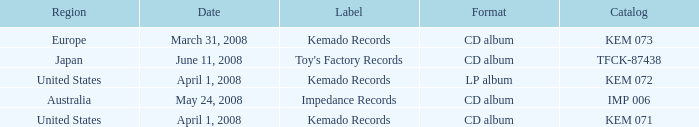Write the full table. {'header': ['Region', 'Date', 'Label', 'Format', 'Catalog'], 'rows': [['Europe', 'March 31, 2008', 'Kemado Records', 'CD album', 'KEM 073'], ['Japan', 'June 11, 2008', "Toy's Factory Records", 'CD album', 'TFCK-87438'], ['United States', 'April 1, 2008', 'Kemado Records', 'LP album', 'KEM 072'], ['Australia', 'May 24, 2008', 'Impedance Records', 'CD album', 'IMP 006'], ['United States', 'April 1, 2008', 'Kemado Records', 'CD album', 'KEM 071']]} Which Region has a Catalog of kem 072? United States. 